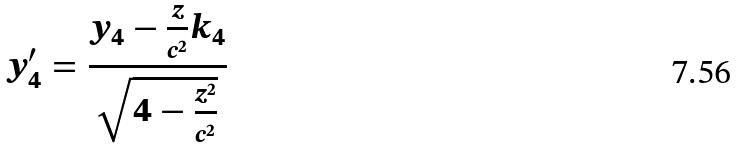<formula> <loc_0><loc_0><loc_500><loc_500>y _ { 4 } ^ { \prime } = \frac { y _ { 4 } - \frac { z } { c ^ { 2 } } k _ { 4 } } { \sqrt { 4 - \frac { z ^ { 2 } } { c ^ { 2 } } } }</formula> 